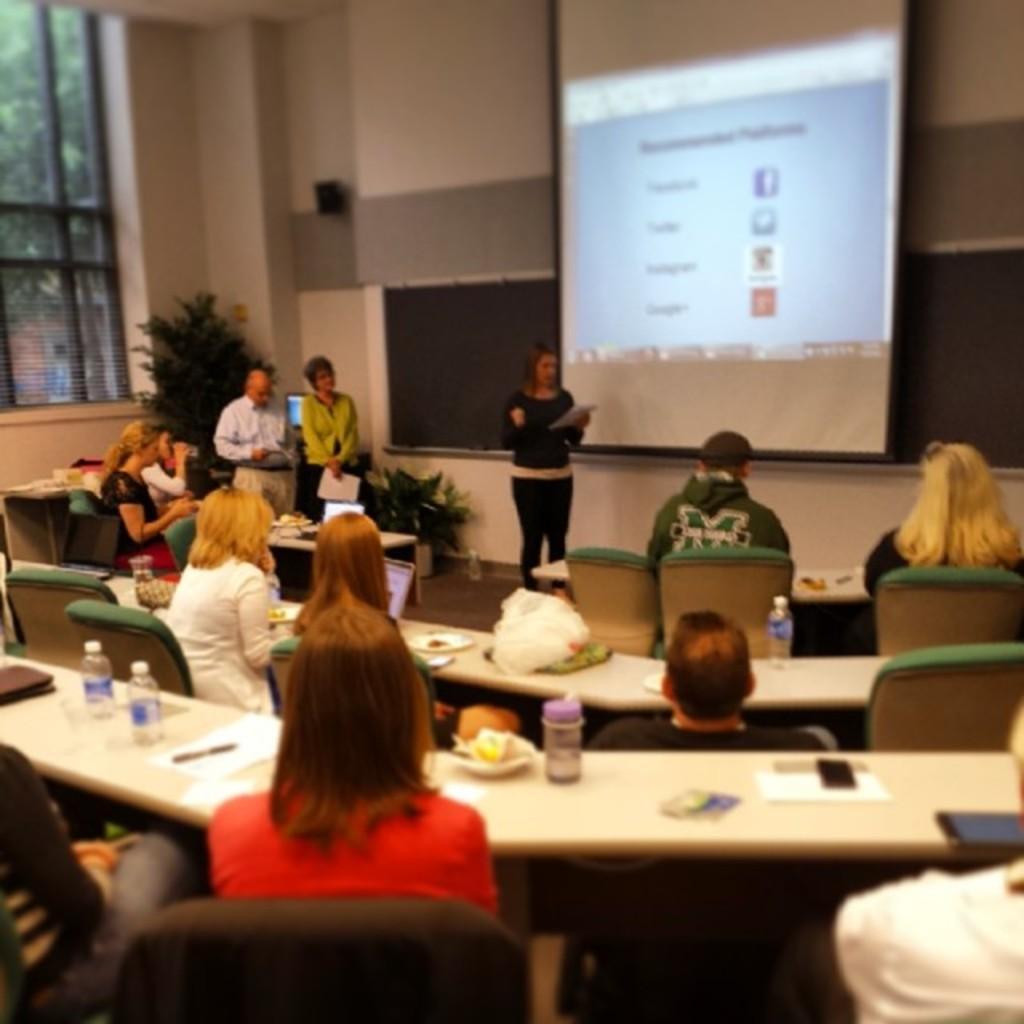Could you give a brief overview of what you see in this image? In this image, we can see a few people. Among them, some people are sitting on chairs. We can see some tables with objects like bottles and posters. We can also see the wall. We can also see some objects. We can see the screen and a board. We can see a plant and a tree. 